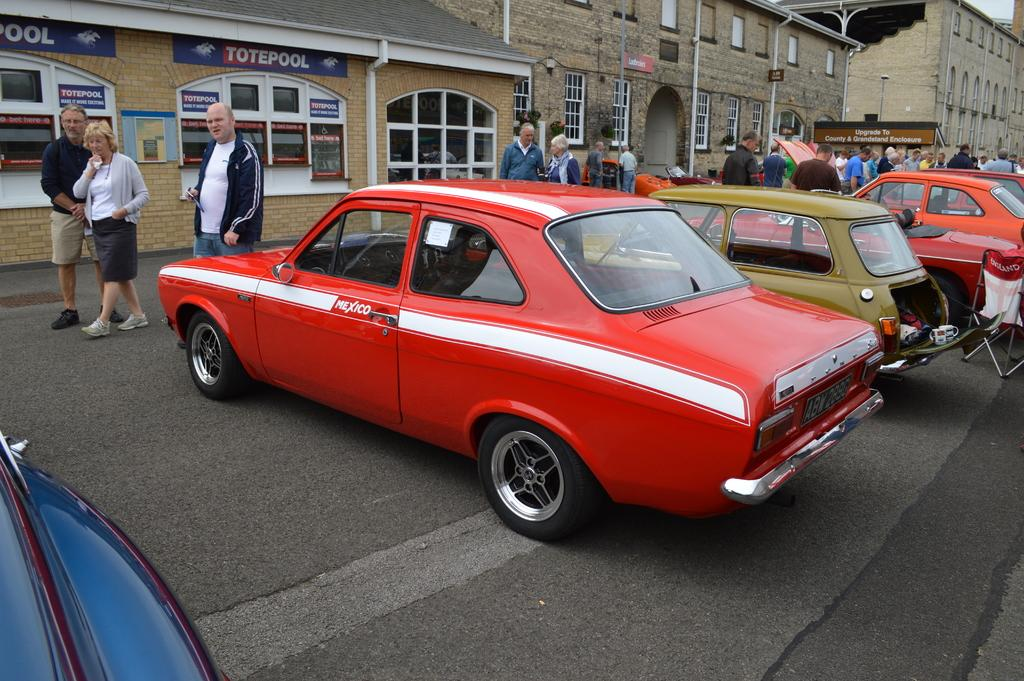What can be seen on the road in the image? There are many cars on the road in the image. What is visible in the background of the image? There is a group of people, buildings, poles, sign boards, and the sky visible in the background of the image. Where is the father standing with his net in the image? There is no father or net present in the image. What is the father trying to control in the image? There is no father or control-related activity depicted in the image. 